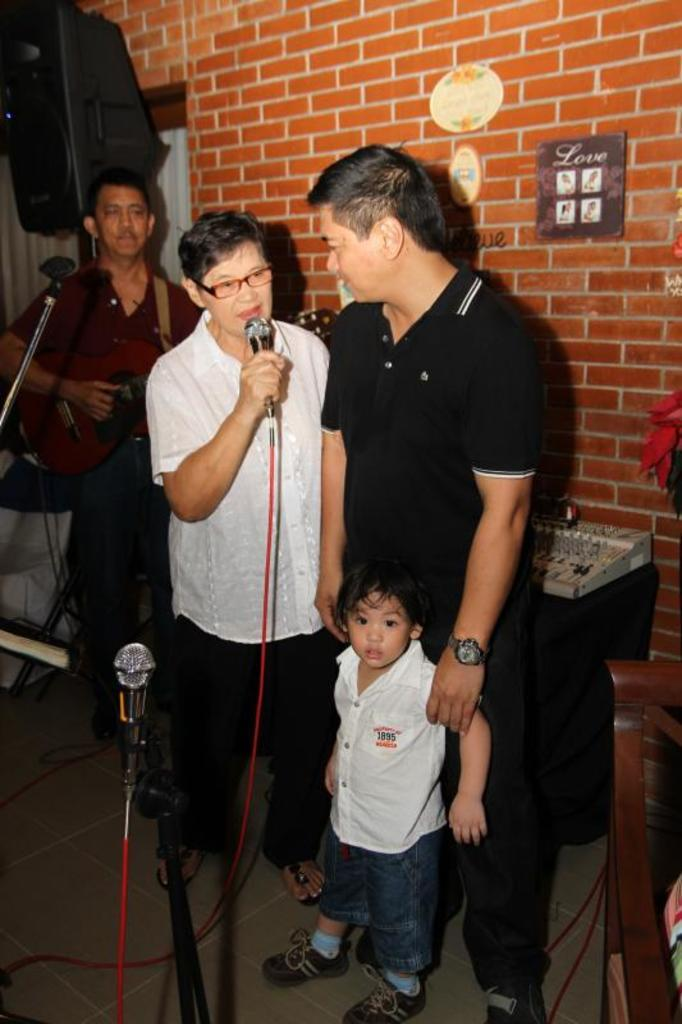How many people are present in the image? There are three members and a kid standing in the image, making a total of four people. What is the guy in the middle holding in his hand? The guy in the middle is holding a mic in his hand. What can be seen in the background of the image? There is a wall in the background of the image. What type of education is being taught at the desk in the image? There is no desk present in the image, so it is not possible to determine what type of education might be taught. 